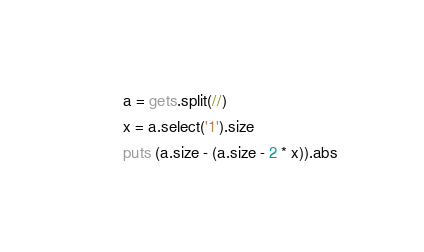Convert code to text. <code><loc_0><loc_0><loc_500><loc_500><_Ruby_>a = gets.split(//)
x = a.select('1').size
puts (a.size - (a.size - 2 * x)).abs
</code> 